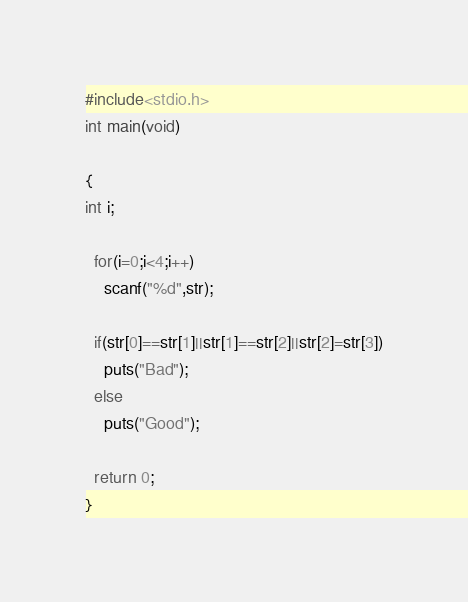Convert code to text. <code><loc_0><loc_0><loc_500><loc_500><_C_>#include<stdio.h>
int main(void)

{
int i;

  for(i=0;i<4;i++)
    scanf("%d",str);
  
  if(str[0]==str[1]||str[1]==str[2]||str[2]=str[3])
    puts("Bad");
  else 
    puts("Good");
  
  return 0;
}
</code> 